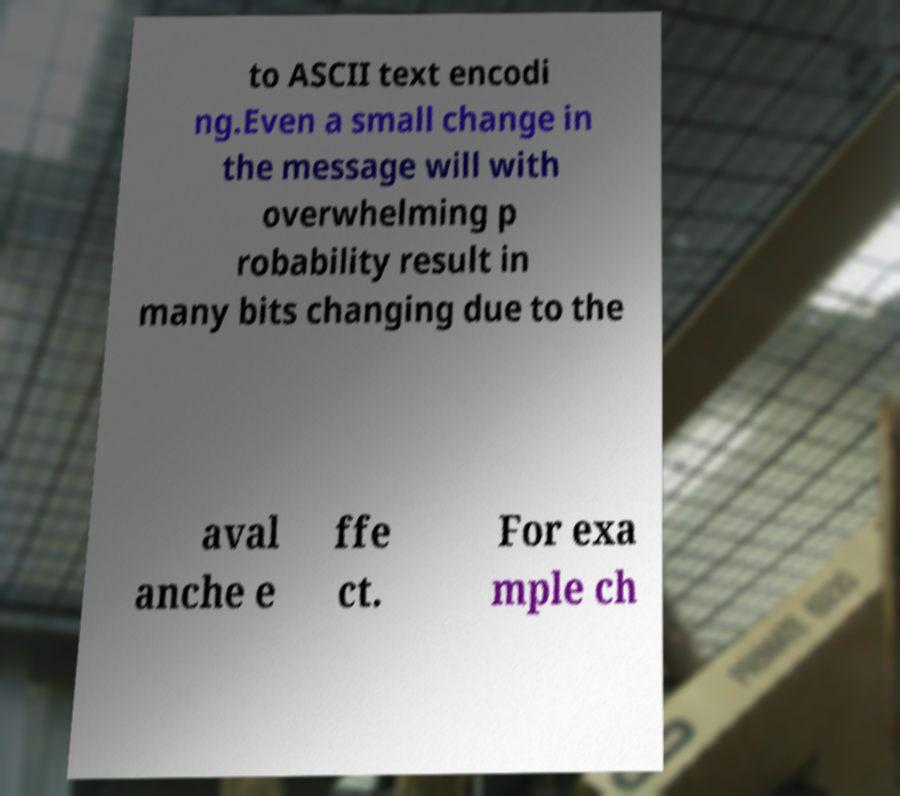I need the written content from this picture converted into text. Can you do that? to ASCII text encodi ng.Even a small change in the message will with overwhelming p robability result in many bits changing due to the aval anche e ffe ct. For exa mple ch 